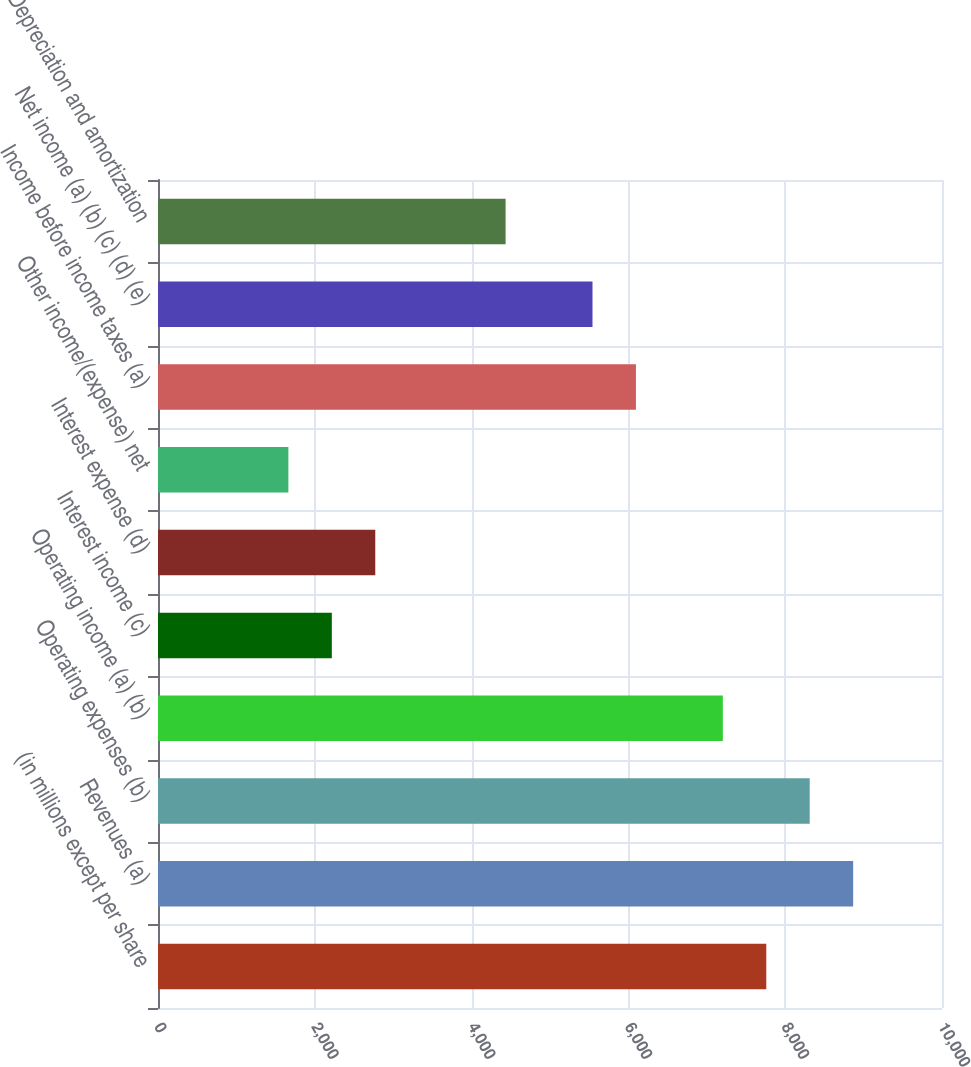Convert chart to OTSL. <chart><loc_0><loc_0><loc_500><loc_500><bar_chart><fcel>(in millions except per share<fcel>Revenues (a)<fcel>Operating expenses (b)<fcel>Operating income (a) (b)<fcel>Interest income (c)<fcel>Interest expense (d)<fcel>Other income/(expense) net<fcel>Income before income taxes (a)<fcel>Net income (a) (b) (c) (d) (e)<fcel>Depreciation and amortization<nl><fcel>7758.6<fcel>8866.9<fcel>8312.75<fcel>7204.45<fcel>2217.1<fcel>2771.25<fcel>1662.95<fcel>6096.15<fcel>5542<fcel>4433.7<nl></chart> 